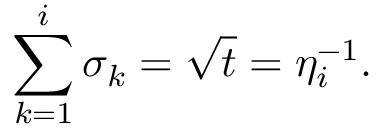<formula> <loc_0><loc_0><loc_500><loc_500>\sum _ { k = 1 } ^ { i } { \sigma _ { k } = \sqrt { t } = \eta _ { i } ^ { - 1 } } .</formula> 